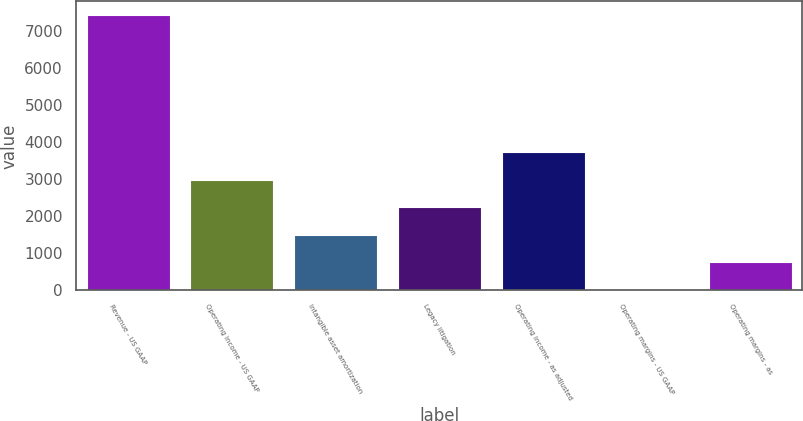<chart> <loc_0><loc_0><loc_500><loc_500><bar_chart><fcel>Revenue - US GAAP<fcel>Operating income - US GAAP<fcel>Intangible asset amortization<fcel>Legacy litigation<fcel>Operating income - as adjusted<fcel>Operating margins - US GAAP<fcel>Operating margins - as<nl><fcel>7426<fcel>2982.58<fcel>1501.44<fcel>2242.01<fcel>3723.15<fcel>20.3<fcel>760.87<nl></chart> 